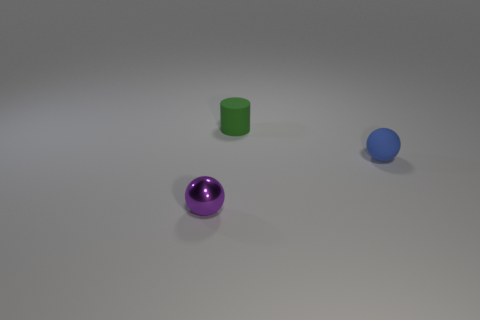What time of day does this lighting suggest? Given that this is likely a controlled environment with artificial lighting—as indicated by the even distribution of light and soft shadows—it is difficult to determine the time of day based on this image alone. This setting doesn’t resemble natural daylight conditions. 